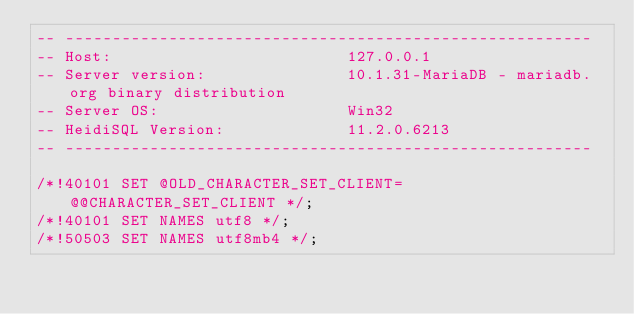<code> <loc_0><loc_0><loc_500><loc_500><_SQL_>-- --------------------------------------------------------
-- Host:                         127.0.0.1
-- Server version:               10.1.31-MariaDB - mariadb.org binary distribution
-- Server OS:                    Win32
-- HeidiSQL Version:             11.2.0.6213
-- --------------------------------------------------------

/*!40101 SET @OLD_CHARACTER_SET_CLIENT=@@CHARACTER_SET_CLIENT */;
/*!40101 SET NAMES utf8 */;
/*!50503 SET NAMES utf8mb4 */;</code> 